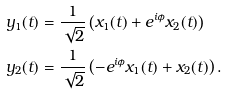<formula> <loc_0><loc_0><loc_500><loc_500>y _ { 1 } ( t ) & = \frac { 1 } { \sqrt { 2 } } \left ( x _ { 1 } ( t ) + e ^ { i \phi } x _ { 2 } ( t ) \right ) \\ y _ { 2 } ( t ) & = \frac { 1 } { \sqrt { 2 } } \left ( - e ^ { i \phi } x _ { 1 } ( t ) + x _ { 2 } ( t ) \right ) .</formula> 